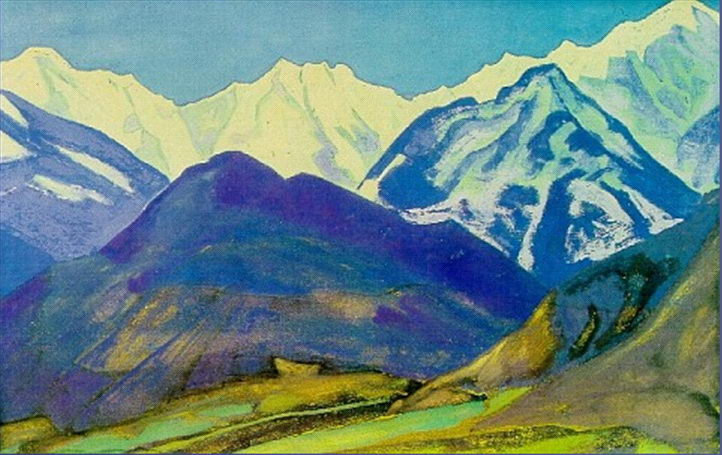If you were to visit this place, what kind of activities could you do? Visiting this splendid mountain landscape would offer a plethora of activities. You could embark on hiking adventures along the verdant valleys, take in panoramic views from different vantage points, or perhaps enjoy a serene picnic beside the small body of water in the foreground. For the more adventurous, there would likely be opportunities for mountaineering or even paragliding, given the towering peaks and open expanses. The tranquil environment also seems perfect for plein air painting, allowing artists to capture the mesmerizing scenery on canvas. What kind of weather might you expect in this location? Given the depicted season, one might expect mild to warm temperatures in the valley with occasional cool breezes. The weather could likely be quite variable, with clear, sunny days perfect for viewing the landscape's vibrant colors and contrasting with potentially cooler, overcast days where the mountains might take on a mysterious, fog-shrouded appearance. At higher elevations, it would be more likely to experience cooler temperatures and even occasional snow showers. 